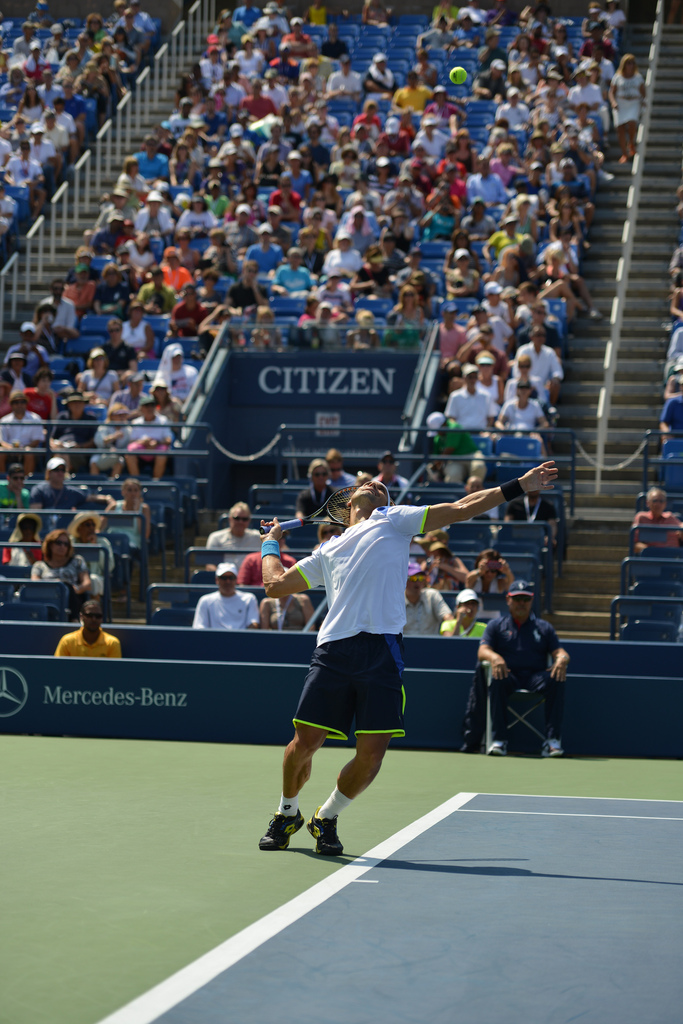Can you describe the type of tennis court shown in the image? The tennis court in the image is a hard court, likely made of an acrylic layer over a concrete or asphalt foundation. It's characterized by its blue color and white boundary lines, standard for professional games. How does this type of court affect the game? Hard courts typically offer a faster game compared to clay or grass courts. The surface provides a stable, even bounce, but it can be tough on players’ joints due to its rigidity. 